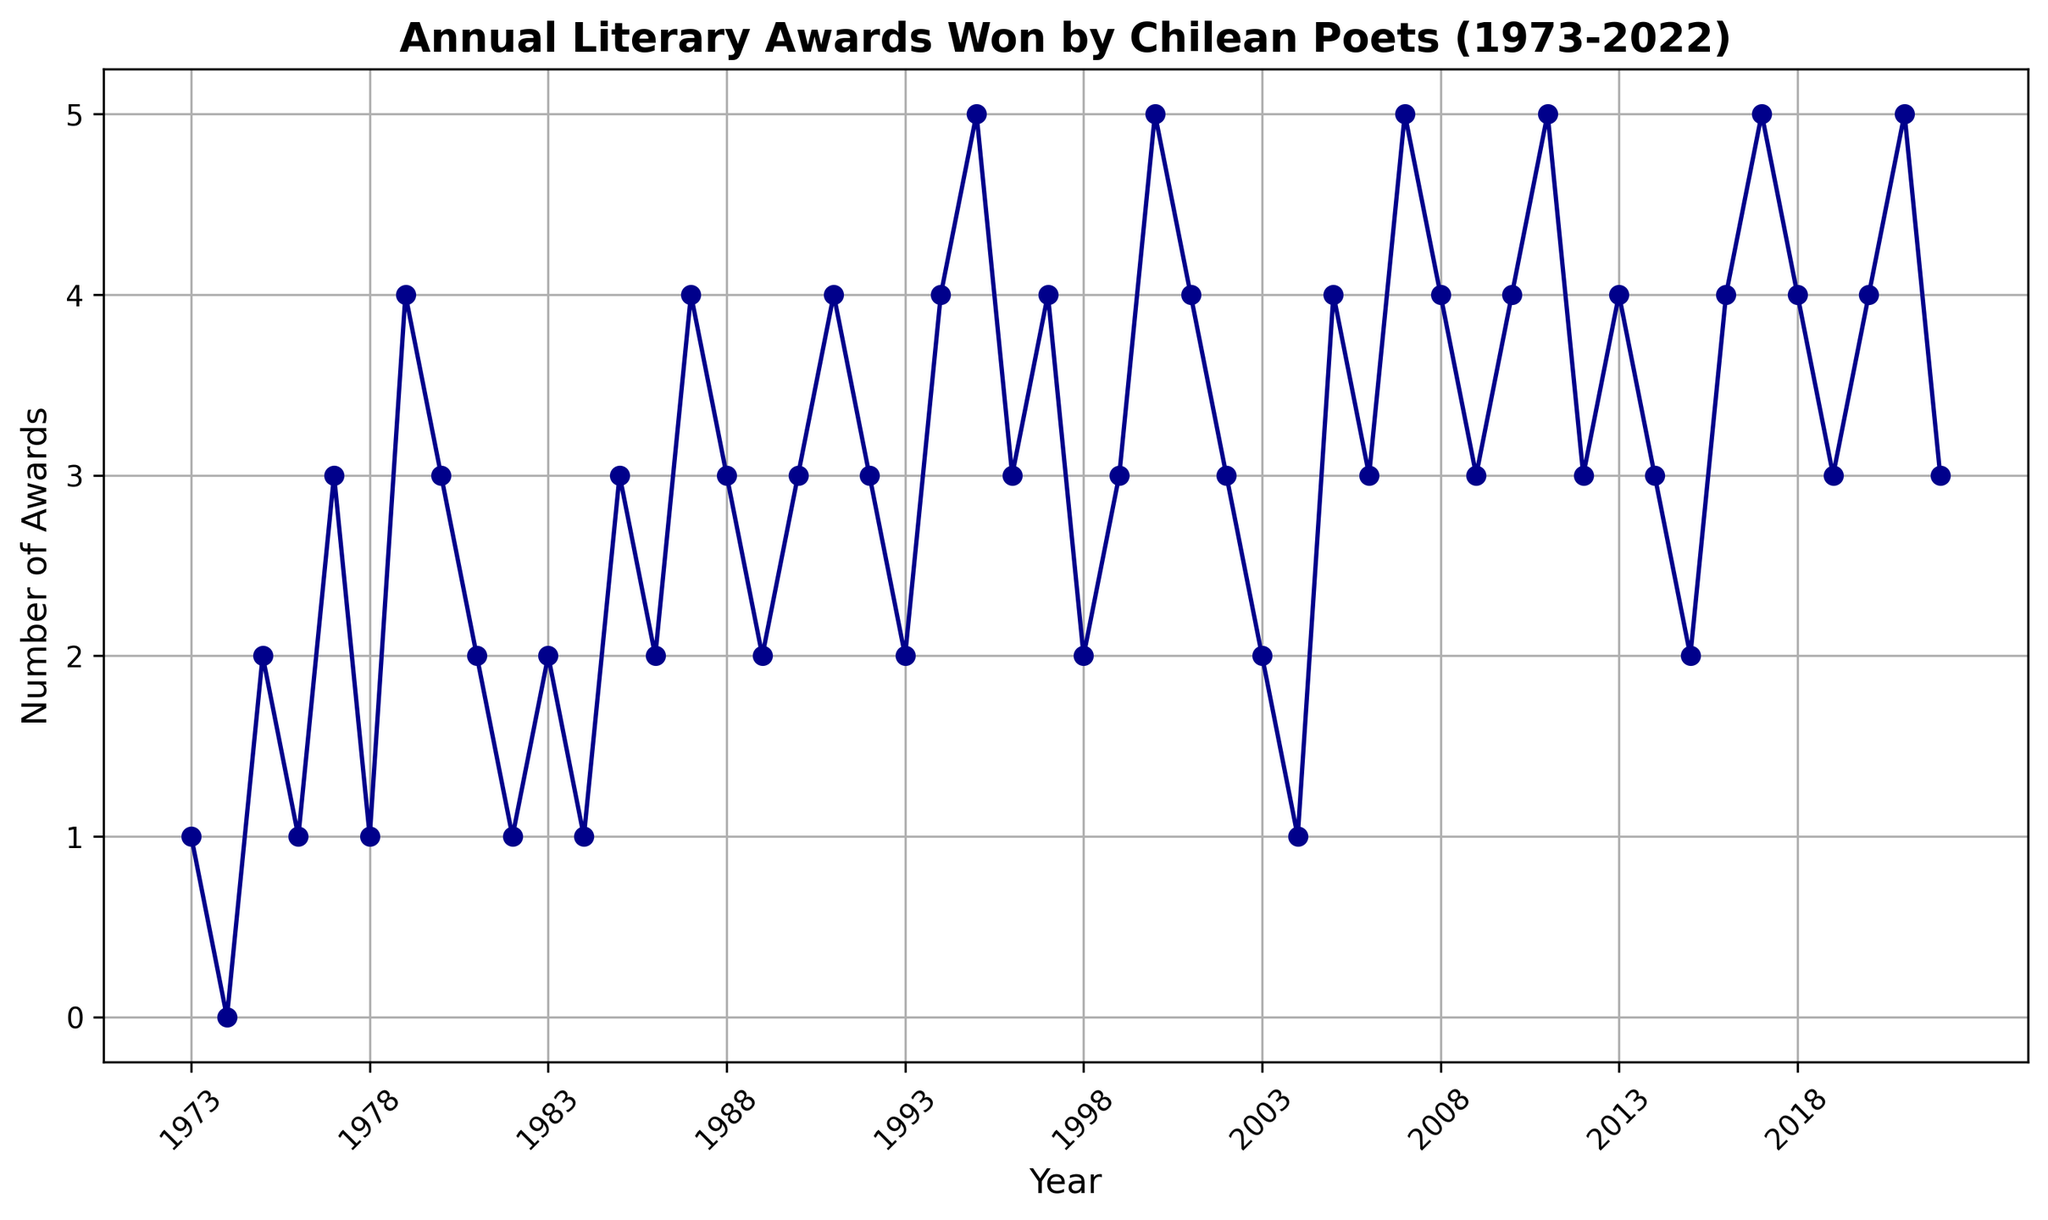What is the trend in the number of literary awards won from 1975 to 1980? Looking at the years from 1975 to 1980 on the x-axis and observing the data points corresponding to these years on the line chart, we can see that the number of awards generally decreases after a peak in 1979, from 2 in 1975, to 4 in 1979, and then it decreases to 3 in 1980.
Answer: Decreasing Which year had the highest number of awards? Observe the y-axis to determine the highest point on the line chart. The highest number of awards, 5, occurs several times: in 1995, 2000, 2007, 2011, 2017, and 2021.
Answer: 1995, 2000, 2007, 2011, 2017, and 2021 How many times did Chilean poets win 3 awards in a year? Count the number of points on the y-axis where the value is 3. These points appear in 1980, 1988, 1992, 1996, 1999, 2002, 2006, 2009, 2012, 2014, and 2019, accounting for a total of 11 times.
Answer: 11 times What was the total number of literary awards won in the 1990s? Add the number of awards from each year in the 1990s: 3 (1990) + 4 (1991) + 3 (1992) + 2 (1993) + 4 (1994) + 5 (1995) + 3 (1996) + 4 (1997) + 2 (1998) + 3 (1999) = 33.
Answer: 33 Compare the number of awards won in 1987 with those won in 1988. Which year had more awards? Look at the data points for 1987 and 1988 on the line chart. In 1987, there are 4 awards, while in 1988, there are 3 awards. Therefore, 1987 had more awards.
Answer: 1987 What's the average number of awards won per year in the 2010s (2010-2019)? Sum the number of awards for each year from 2010 to 2019 and divide by the number of years (10): (4 + 5 + 3 + 4 + 3 + 2 + 4 + 5 + 4 + 3) / 10 = 37 / 10 = 3.7.
Answer: 3.7 